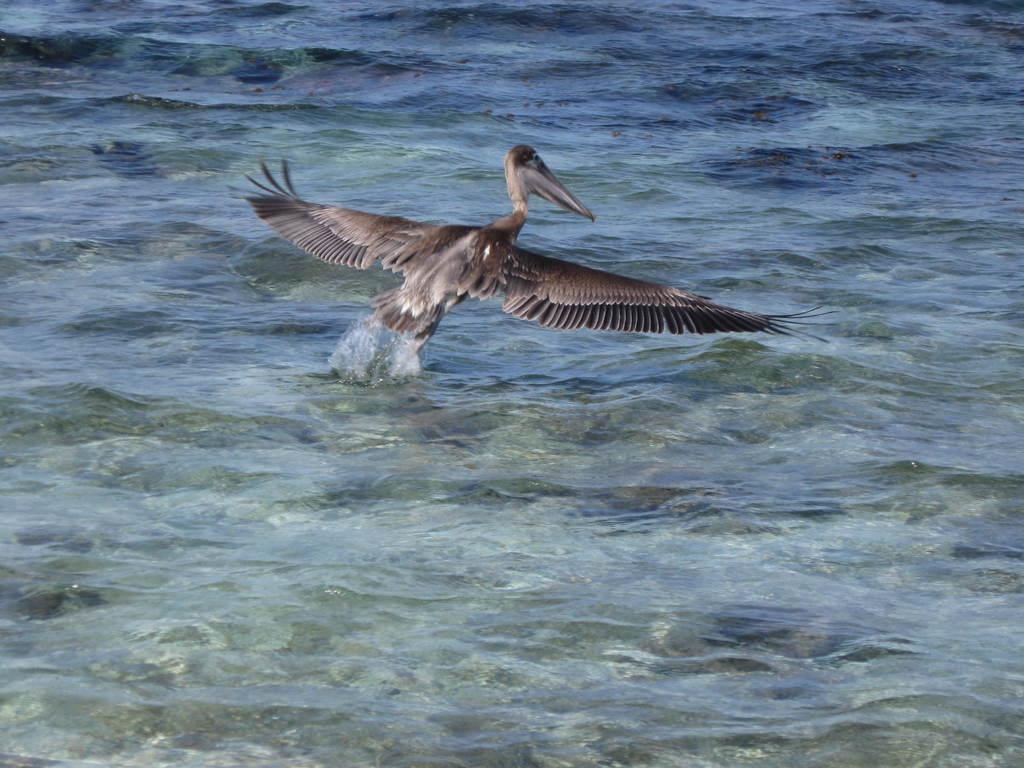Can you describe this image briefly? Here in this picture we can see a brown pelican flying in air and we can see water present all over there below it. 